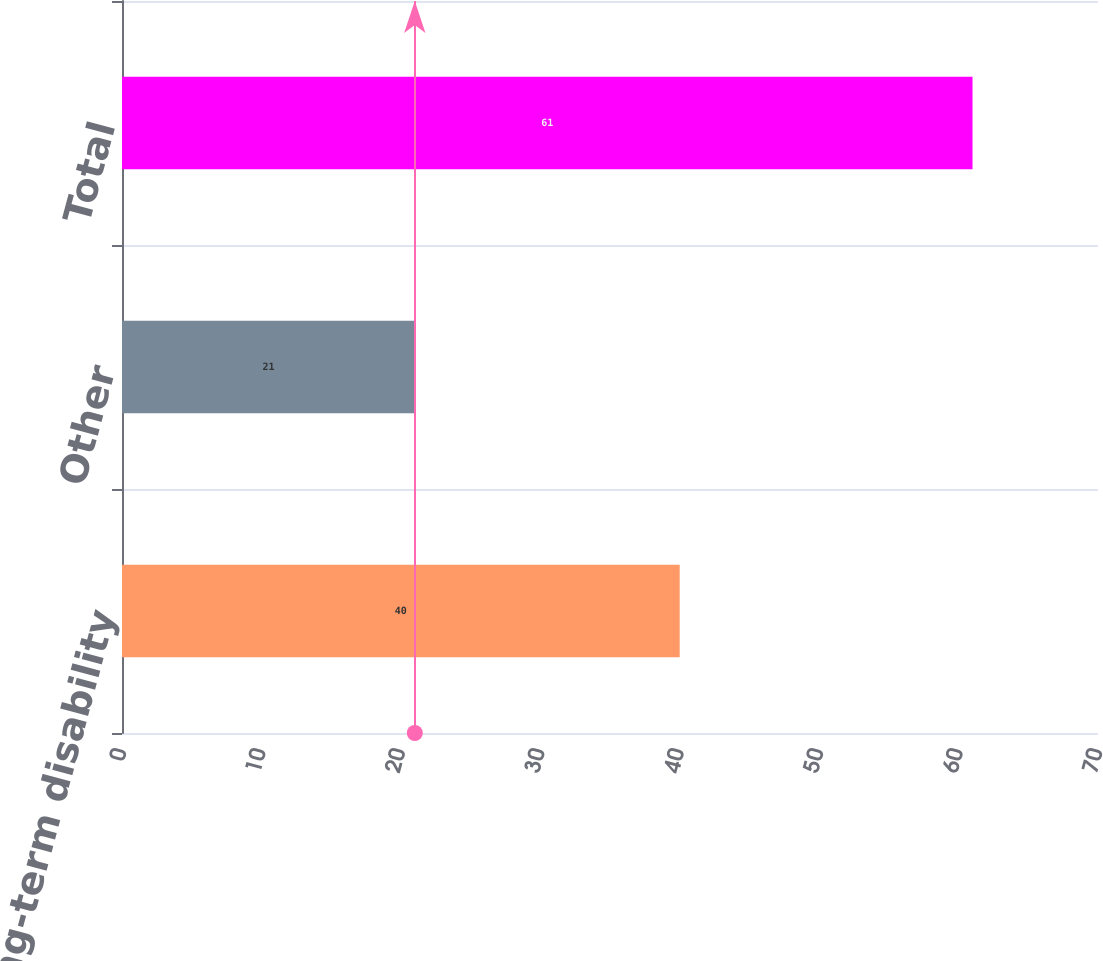Convert chart to OTSL. <chart><loc_0><loc_0><loc_500><loc_500><bar_chart><fcel>Long-term disability<fcel>Other<fcel>Total<nl><fcel>40<fcel>21<fcel>61<nl></chart> 